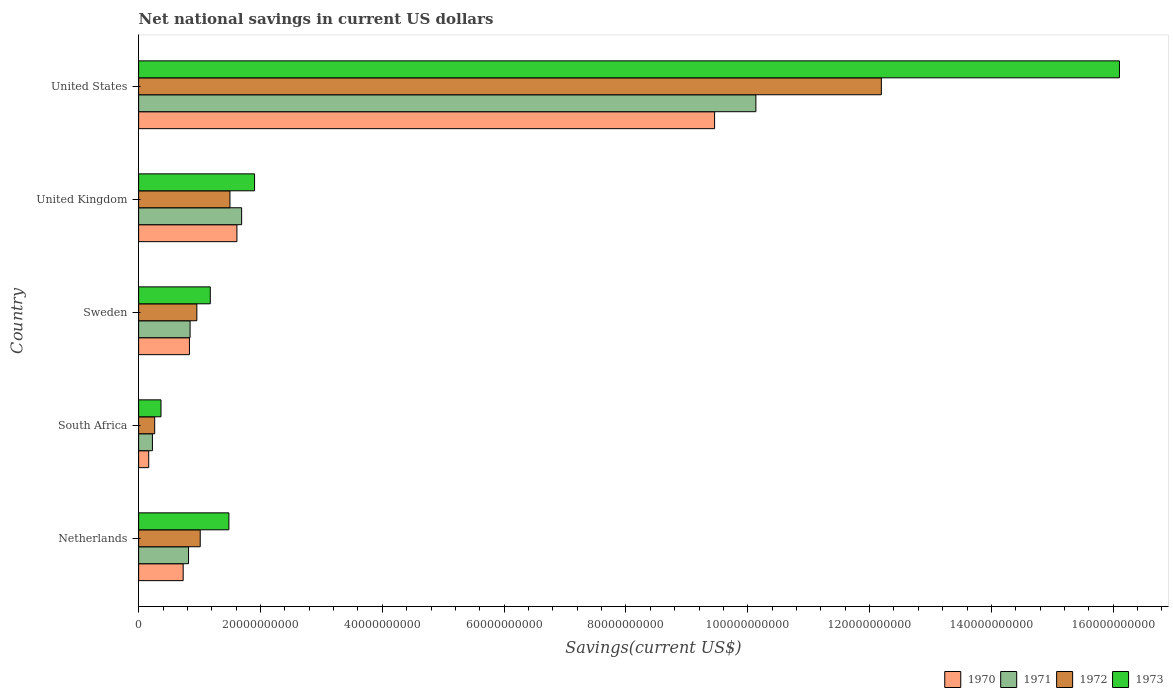How many groups of bars are there?
Offer a very short reply. 5. How many bars are there on the 3rd tick from the top?
Provide a succinct answer. 4. How many bars are there on the 5th tick from the bottom?
Give a very brief answer. 4. What is the net national savings in 1971 in United Kingdom?
Offer a terse response. 1.69e+1. Across all countries, what is the maximum net national savings in 1971?
Keep it short and to the point. 1.01e+11. Across all countries, what is the minimum net national savings in 1970?
Ensure brevity in your answer.  1.66e+09. In which country was the net national savings in 1970 maximum?
Provide a succinct answer. United States. In which country was the net national savings in 1970 minimum?
Give a very brief answer. South Africa. What is the total net national savings in 1972 in the graph?
Ensure brevity in your answer.  1.59e+11. What is the difference between the net national savings in 1970 in South Africa and that in United Kingdom?
Your response must be concise. -1.45e+1. What is the difference between the net national savings in 1973 in South Africa and the net national savings in 1971 in Netherlands?
Offer a very short reply. -4.52e+09. What is the average net national savings in 1973 per country?
Offer a very short reply. 4.21e+1. What is the difference between the net national savings in 1970 and net national savings in 1973 in South Africa?
Give a very brief answer. -2.02e+09. What is the ratio of the net national savings in 1970 in Netherlands to that in Sweden?
Your answer should be very brief. 0.88. Is the net national savings in 1973 in South Africa less than that in Sweden?
Offer a very short reply. Yes. What is the difference between the highest and the second highest net national savings in 1970?
Your answer should be very brief. 7.84e+1. What is the difference between the highest and the lowest net national savings in 1971?
Provide a succinct answer. 9.91e+1. What does the 3rd bar from the top in United Kingdom represents?
Provide a short and direct response. 1971. What does the 3rd bar from the bottom in South Africa represents?
Your answer should be very brief. 1972. Is it the case that in every country, the sum of the net national savings in 1972 and net national savings in 1971 is greater than the net national savings in 1973?
Give a very brief answer. Yes. Are all the bars in the graph horizontal?
Provide a short and direct response. Yes. What is the difference between two consecutive major ticks on the X-axis?
Ensure brevity in your answer.  2.00e+1. How many legend labels are there?
Keep it short and to the point. 4. What is the title of the graph?
Your response must be concise. Net national savings in current US dollars. What is the label or title of the X-axis?
Offer a very short reply. Savings(current US$). What is the label or title of the Y-axis?
Offer a terse response. Country. What is the Savings(current US$) of 1970 in Netherlands?
Your response must be concise. 7.31e+09. What is the Savings(current US$) in 1971 in Netherlands?
Your response must be concise. 8.20e+09. What is the Savings(current US$) of 1972 in Netherlands?
Give a very brief answer. 1.01e+1. What is the Savings(current US$) in 1973 in Netherlands?
Offer a very short reply. 1.48e+1. What is the Savings(current US$) in 1970 in South Africa?
Provide a short and direct response. 1.66e+09. What is the Savings(current US$) in 1971 in South Africa?
Your answer should be very brief. 2.27e+09. What is the Savings(current US$) in 1972 in South Africa?
Ensure brevity in your answer.  2.64e+09. What is the Savings(current US$) of 1973 in South Africa?
Provide a succinct answer. 3.67e+09. What is the Savings(current US$) in 1970 in Sweden?
Your answer should be compact. 8.34e+09. What is the Savings(current US$) in 1971 in Sweden?
Keep it short and to the point. 8.45e+09. What is the Savings(current US$) in 1972 in Sweden?
Offer a terse response. 9.56e+09. What is the Savings(current US$) of 1973 in Sweden?
Provide a succinct answer. 1.18e+1. What is the Savings(current US$) in 1970 in United Kingdom?
Your answer should be compact. 1.61e+1. What is the Savings(current US$) of 1971 in United Kingdom?
Your answer should be compact. 1.69e+1. What is the Savings(current US$) in 1972 in United Kingdom?
Your response must be concise. 1.50e+1. What is the Savings(current US$) in 1973 in United Kingdom?
Offer a very short reply. 1.90e+1. What is the Savings(current US$) of 1970 in United States?
Your answer should be compact. 9.46e+1. What is the Savings(current US$) in 1971 in United States?
Keep it short and to the point. 1.01e+11. What is the Savings(current US$) in 1972 in United States?
Provide a succinct answer. 1.22e+11. What is the Savings(current US$) of 1973 in United States?
Your answer should be compact. 1.61e+11. Across all countries, what is the maximum Savings(current US$) in 1970?
Offer a very short reply. 9.46e+1. Across all countries, what is the maximum Savings(current US$) of 1971?
Your answer should be very brief. 1.01e+11. Across all countries, what is the maximum Savings(current US$) in 1972?
Ensure brevity in your answer.  1.22e+11. Across all countries, what is the maximum Savings(current US$) of 1973?
Keep it short and to the point. 1.61e+11. Across all countries, what is the minimum Savings(current US$) in 1970?
Your response must be concise. 1.66e+09. Across all countries, what is the minimum Savings(current US$) in 1971?
Offer a terse response. 2.27e+09. Across all countries, what is the minimum Savings(current US$) in 1972?
Keep it short and to the point. 2.64e+09. Across all countries, what is the minimum Savings(current US$) of 1973?
Your answer should be compact. 3.67e+09. What is the total Savings(current US$) of 1970 in the graph?
Offer a terse response. 1.28e+11. What is the total Savings(current US$) of 1971 in the graph?
Keep it short and to the point. 1.37e+11. What is the total Savings(current US$) in 1972 in the graph?
Give a very brief answer. 1.59e+11. What is the total Savings(current US$) in 1973 in the graph?
Your answer should be very brief. 2.10e+11. What is the difference between the Savings(current US$) in 1970 in Netherlands and that in South Africa?
Your answer should be compact. 5.66e+09. What is the difference between the Savings(current US$) of 1971 in Netherlands and that in South Africa?
Your answer should be compact. 5.93e+09. What is the difference between the Savings(current US$) of 1972 in Netherlands and that in South Africa?
Ensure brevity in your answer.  7.48e+09. What is the difference between the Savings(current US$) of 1973 in Netherlands and that in South Africa?
Ensure brevity in your answer.  1.11e+1. What is the difference between the Savings(current US$) of 1970 in Netherlands and that in Sweden?
Your answer should be very brief. -1.03e+09. What is the difference between the Savings(current US$) in 1971 in Netherlands and that in Sweden?
Your response must be concise. -2.53e+08. What is the difference between the Savings(current US$) in 1972 in Netherlands and that in Sweden?
Ensure brevity in your answer.  5.54e+08. What is the difference between the Savings(current US$) in 1973 in Netherlands and that in Sweden?
Provide a short and direct response. 3.06e+09. What is the difference between the Savings(current US$) of 1970 in Netherlands and that in United Kingdom?
Your answer should be compact. -8.83e+09. What is the difference between the Savings(current US$) in 1971 in Netherlands and that in United Kingdom?
Keep it short and to the point. -8.72e+09. What is the difference between the Savings(current US$) of 1972 in Netherlands and that in United Kingdom?
Your answer should be very brief. -4.88e+09. What is the difference between the Savings(current US$) of 1973 in Netherlands and that in United Kingdom?
Your answer should be compact. -4.22e+09. What is the difference between the Savings(current US$) of 1970 in Netherlands and that in United States?
Offer a terse response. -8.72e+1. What is the difference between the Savings(current US$) in 1971 in Netherlands and that in United States?
Make the answer very short. -9.31e+1. What is the difference between the Savings(current US$) of 1972 in Netherlands and that in United States?
Provide a short and direct response. -1.12e+11. What is the difference between the Savings(current US$) in 1973 in Netherlands and that in United States?
Your answer should be compact. -1.46e+11. What is the difference between the Savings(current US$) of 1970 in South Africa and that in Sweden?
Keep it short and to the point. -6.69e+09. What is the difference between the Savings(current US$) in 1971 in South Africa and that in Sweden?
Offer a terse response. -6.18e+09. What is the difference between the Savings(current US$) of 1972 in South Africa and that in Sweden?
Your response must be concise. -6.92e+09. What is the difference between the Savings(current US$) of 1973 in South Africa and that in Sweden?
Provide a short and direct response. -8.09e+09. What is the difference between the Savings(current US$) of 1970 in South Africa and that in United Kingdom?
Give a very brief answer. -1.45e+1. What is the difference between the Savings(current US$) in 1971 in South Africa and that in United Kingdom?
Your answer should be compact. -1.46e+1. What is the difference between the Savings(current US$) in 1972 in South Africa and that in United Kingdom?
Make the answer very short. -1.24e+1. What is the difference between the Savings(current US$) of 1973 in South Africa and that in United Kingdom?
Provide a succinct answer. -1.54e+1. What is the difference between the Savings(current US$) in 1970 in South Africa and that in United States?
Give a very brief answer. -9.29e+1. What is the difference between the Savings(current US$) in 1971 in South Africa and that in United States?
Provide a succinct answer. -9.91e+1. What is the difference between the Savings(current US$) in 1972 in South Africa and that in United States?
Your answer should be very brief. -1.19e+11. What is the difference between the Savings(current US$) in 1973 in South Africa and that in United States?
Ensure brevity in your answer.  -1.57e+11. What is the difference between the Savings(current US$) in 1970 in Sweden and that in United Kingdom?
Provide a succinct answer. -7.80e+09. What is the difference between the Savings(current US$) of 1971 in Sweden and that in United Kingdom?
Ensure brevity in your answer.  -8.46e+09. What is the difference between the Savings(current US$) of 1972 in Sweden and that in United Kingdom?
Your response must be concise. -5.43e+09. What is the difference between the Savings(current US$) in 1973 in Sweden and that in United Kingdom?
Offer a very short reply. -7.27e+09. What is the difference between the Savings(current US$) of 1970 in Sweden and that in United States?
Your response must be concise. -8.62e+1. What is the difference between the Savings(current US$) in 1971 in Sweden and that in United States?
Ensure brevity in your answer.  -9.29e+1. What is the difference between the Savings(current US$) of 1972 in Sweden and that in United States?
Give a very brief answer. -1.12e+11. What is the difference between the Savings(current US$) of 1973 in Sweden and that in United States?
Provide a succinct answer. -1.49e+11. What is the difference between the Savings(current US$) of 1970 in United Kingdom and that in United States?
Your response must be concise. -7.84e+1. What is the difference between the Savings(current US$) in 1971 in United Kingdom and that in United States?
Give a very brief answer. -8.44e+1. What is the difference between the Savings(current US$) in 1972 in United Kingdom and that in United States?
Your response must be concise. -1.07e+11. What is the difference between the Savings(current US$) of 1973 in United Kingdom and that in United States?
Keep it short and to the point. -1.42e+11. What is the difference between the Savings(current US$) in 1970 in Netherlands and the Savings(current US$) in 1971 in South Africa?
Make the answer very short. 5.05e+09. What is the difference between the Savings(current US$) of 1970 in Netherlands and the Savings(current US$) of 1972 in South Africa?
Ensure brevity in your answer.  4.68e+09. What is the difference between the Savings(current US$) in 1970 in Netherlands and the Savings(current US$) in 1973 in South Africa?
Offer a very short reply. 3.64e+09. What is the difference between the Savings(current US$) in 1971 in Netherlands and the Savings(current US$) in 1972 in South Africa?
Offer a terse response. 5.56e+09. What is the difference between the Savings(current US$) of 1971 in Netherlands and the Savings(current US$) of 1973 in South Africa?
Your response must be concise. 4.52e+09. What is the difference between the Savings(current US$) in 1972 in Netherlands and the Savings(current US$) in 1973 in South Africa?
Provide a short and direct response. 6.44e+09. What is the difference between the Savings(current US$) in 1970 in Netherlands and the Savings(current US$) in 1971 in Sweden?
Offer a very short reply. -1.14e+09. What is the difference between the Savings(current US$) of 1970 in Netherlands and the Savings(current US$) of 1972 in Sweden?
Your answer should be compact. -2.25e+09. What is the difference between the Savings(current US$) of 1970 in Netherlands and the Savings(current US$) of 1973 in Sweden?
Offer a very short reply. -4.45e+09. What is the difference between the Savings(current US$) in 1971 in Netherlands and the Savings(current US$) in 1972 in Sweden?
Keep it short and to the point. -1.36e+09. What is the difference between the Savings(current US$) in 1971 in Netherlands and the Savings(current US$) in 1973 in Sweden?
Your answer should be compact. -3.57e+09. What is the difference between the Savings(current US$) of 1972 in Netherlands and the Savings(current US$) of 1973 in Sweden?
Keep it short and to the point. -1.65e+09. What is the difference between the Savings(current US$) of 1970 in Netherlands and the Savings(current US$) of 1971 in United Kingdom?
Keep it short and to the point. -9.60e+09. What is the difference between the Savings(current US$) in 1970 in Netherlands and the Savings(current US$) in 1972 in United Kingdom?
Offer a terse response. -7.68e+09. What is the difference between the Savings(current US$) of 1970 in Netherlands and the Savings(current US$) of 1973 in United Kingdom?
Ensure brevity in your answer.  -1.17e+1. What is the difference between the Savings(current US$) of 1971 in Netherlands and the Savings(current US$) of 1972 in United Kingdom?
Make the answer very short. -6.80e+09. What is the difference between the Savings(current US$) in 1971 in Netherlands and the Savings(current US$) in 1973 in United Kingdom?
Provide a succinct answer. -1.08e+1. What is the difference between the Savings(current US$) of 1972 in Netherlands and the Savings(current US$) of 1973 in United Kingdom?
Offer a terse response. -8.92e+09. What is the difference between the Savings(current US$) of 1970 in Netherlands and the Savings(current US$) of 1971 in United States?
Provide a short and direct response. -9.40e+1. What is the difference between the Savings(current US$) of 1970 in Netherlands and the Savings(current US$) of 1972 in United States?
Provide a succinct answer. -1.15e+11. What is the difference between the Savings(current US$) of 1970 in Netherlands and the Savings(current US$) of 1973 in United States?
Ensure brevity in your answer.  -1.54e+11. What is the difference between the Savings(current US$) in 1971 in Netherlands and the Savings(current US$) in 1972 in United States?
Your response must be concise. -1.14e+11. What is the difference between the Savings(current US$) in 1971 in Netherlands and the Savings(current US$) in 1973 in United States?
Your answer should be very brief. -1.53e+11. What is the difference between the Savings(current US$) in 1972 in Netherlands and the Savings(current US$) in 1973 in United States?
Your response must be concise. -1.51e+11. What is the difference between the Savings(current US$) of 1970 in South Africa and the Savings(current US$) of 1971 in Sweden?
Provide a short and direct response. -6.79e+09. What is the difference between the Savings(current US$) of 1970 in South Africa and the Savings(current US$) of 1972 in Sweden?
Make the answer very short. -7.90e+09. What is the difference between the Savings(current US$) of 1970 in South Africa and the Savings(current US$) of 1973 in Sweden?
Provide a succinct answer. -1.01e+1. What is the difference between the Savings(current US$) of 1971 in South Africa and the Savings(current US$) of 1972 in Sweden?
Your response must be concise. -7.29e+09. What is the difference between the Savings(current US$) in 1971 in South Africa and the Savings(current US$) in 1973 in Sweden?
Provide a short and direct response. -9.50e+09. What is the difference between the Savings(current US$) in 1972 in South Africa and the Savings(current US$) in 1973 in Sweden?
Ensure brevity in your answer.  -9.13e+09. What is the difference between the Savings(current US$) of 1970 in South Africa and the Savings(current US$) of 1971 in United Kingdom?
Make the answer very short. -1.53e+1. What is the difference between the Savings(current US$) in 1970 in South Africa and the Savings(current US$) in 1972 in United Kingdom?
Your answer should be very brief. -1.33e+1. What is the difference between the Savings(current US$) of 1970 in South Africa and the Savings(current US$) of 1973 in United Kingdom?
Ensure brevity in your answer.  -1.74e+1. What is the difference between the Savings(current US$) in 1971 in South Africa and the Savings(current US$) in 1972 in United Kingdom?
Offer a terse response. -1.27e+1. What is the difference between the Savings(current US$) of 1971 in South Africa and the Savings(current US$) of 1973 in United Kingdom?
Keep it short and to the point. -1.68e+1. What is the difference between the Savings(current US$) in 1972 in South Africa and the Savings(current US$) in 1973 in United Kingdom?
Your answer should be very brief. -1.64e+1. What is the difference between the Savings(current US$) of 1970 in South Africa and the Savings(current US$) of 1971 in United States?
Provide a short and direct response. -9.97e+1. What is the difference between the Savings(current US$) in 1970 in South Africa and the Savings(current US$) in 1972 in United States?
Your response must be concise. -1.20e+11. What is the difference between the Savings(current US$) in 1970 in South Africa and the Savings(current US$) in 1973 in United States?
Provide a short and direct response. -1.59e+11. What is the difference between the Savings(current US$) of 1971 in South Africa and the Savings(current US$) of 1972 in United States?
Ensure brevity in your answer.  -1.20e+11. What is the difference between the Savings(current US$) of 1971 in South Africa and the Savings(current US$) of 1973 in United States?
Your answer should be very brief. -1.59e+11. What is the difference between the Savings(current US$) in 1972 in South Africa and the Savings(current US$) in 1973 in United States?
Offer a very short reply. -1.58e+11. What is the difference between the Savings(current US$) of 1970 in Sweden and the Savings(current US$) of 1971 in United Kingdom?
Provide a short and direct response. -8.57e+09. What is the difference between the Savings(current US$) of 1970 in Sweden and the Savings(current US$) of 1972 in United Kingdom?
Give a very brief answer. -6.65e+09. What is the difference between the Savings(current US$) of 1970 in Sweden and the Savings(current US$) of 1973 in United Kingdom?
Ensure brevity in your answer.  -1.07e+1. What is the difference between the Savings(current US$) in 1971 in Sweden and the Savings(current US$) in 1972 in United Kingdom?
Give a very brief answer. -6.54e+09. What is the difference between the Savings(current US$) of 1971 in Sweden and the Savings(current US$) of 1973 in United Kingdom?
Make the answer very short. -1.06e+1. What is the difference between the Savings(current US$) of 1972 in Sweden and the Savings(current US$) of 1973 in United Kingdom?
Keep it short and to the point. -9.48e+09. What is the difference between the Savings(current US$) in 1970 in Sweden and the Savings(current US$) in 1971 in United States?
Offer a very short reply. -9.30e+1. What is the difference between the Savings(current US$) in 1970 in Sweden and the Savings(current US$) in 1972 in United States?
Give a very brief answer. -1.14e+11. What is the difference between the Savings(current US$) in 1970 in Sweden and the Savings(current US$) in 1973 in United States?
Provide a succinct answer. -1.53e+11. What is the difference between the Savings(current US$) in 1971 in Sweden and the Savings(current US$) in 1972 in United States?
Your answer should be compact. -1.13e+11. What is the difference between the Savings(current US$) in 1971 in Sweden and the Savings(current US$) in 1973 in United States?
Your answer should be compact. -1.53e+11. What is the difference between the Savings(current US$) in 1972 in Sweden and the Savings(current US$) in 1973 in United States?
Your response must be concise. -1.51e+11. What is the difference between the Savings(current US$) of 1970 in United Kingdom and the Savings(current US$) of 1971 in United States?
Your answer should be compact. -8.52e+1. What is the difference between the Savings(current US$) in 1970 in United Kingdom and the Savings(current US$) in 1972 in United States?
Your answer should be compact. -1.06e+11. What is the difference between the Savings(current US$) in 1970 in United Kingdom and the Savings(current US$) in 1973 in United States?
Make the answer very short. -1.45e+11. What is the difference between the Savings(current US$) in 1971 in United Kingdom and the Savings(current US$) in 1972 in United States?
Provide a short and direct response. -1.05e+11. What is the difference between the Savings(current US$) of 1971 in United Kingdom and the Savings(current US$) of 1973 in United States?
Keep it short and to the point. -1.44e+11. What is the difference between the Savings(current US$) of 1972 in United Kingdom and the Savings(current US$) of 1973 in United States?
Give a very brief answer. -1.46e+11. What is the average Savings(current US$) of 1970 per country?
Your answer should be very brief. 2.56e+1. What is the average Savings(current US$) in 1971 per country?
Provide a succinct answer. 2.74e+1. What is the average Savings(current US$) in 1972 per country?
Offer a terse response. 3.18e+1. What is the average Savings(current US$) in 1973 per country?
Ensure brevity in your answer.  4.21e+1. What is the difference between the Savings(current US$) in 1970 and Savings(current US$) in 1971 in Netherlands?
Provide a succinct answer. -8.83e+08. What is the difference between the Savings(current US$) of 1970 and Savings(current US$) of 1972 in Netherlands?
Your answer should be very brief. -2.80e+09. What is the difference between the Savings(current US$) in 1970 and Savings(current US$) in 1973 in Netherlands?
Provide a short and direct response. -7.51e+09. What is the difference between the Savings(current US$) of 1971 and Savings(current US$) of 1972 in Netherlands?
Your answer should be very brief. -1.92e+09. What is the difference between the Savings(current US$) in 1971 and Savings(current US$) in 1973 in Netherlands?
Offer a very short reply. -6.62e+09. What is the difference between the Savings(current US$) in 1972 and Savings(current US$) in 1973 in Netherlands?
Make the answer very short. -4.71e+09. What is the difference between the Savings(current US$) of 1970 and Savings(current US$) of 1971 in South Africa?
Keep it short and to the point. -6.09e+08. What is the difference between the Savings(current US$) in 1970 and Savings(current US$) in 1972 in South Africa?
Give a very brief answer. -9.79e+08. What is the difference between the Savings(current US$) in 1970 and Savings(current US$) in 1973 in South Africa?
Your answer should be very brief. -2.02e+09. What is the difference between the Savings(current US$) in 1971 and Savings(current US$) in 1972 in South Africa?
Provide a succinct answer. -3.70e+08. What is the difference between the Savings(current US$) of 1971 and Savings(current US$) of 1973 in South Africa?
Offer a terse response. -1.41e+09. What is the difference between the Savings(current US$) in 1972 and Savings(current US$) in 1973 in South Africa?
Make the answer very short. -1.04e+09. What is the difference between the Savings(current US$) in 1970 and Savings(current US$) in 1971 in Sweden?
Your answer should be very brief. -1.07e+08. What is the difference between the Savings(current US$) in 1970 and Savings(current US$) in 1972 in Sweden?
Your answer should be compact. -1.22e+09. What is the difference between the Savings(current US$) in 1970 and Savings(current US$) in 1973 in Sweden?
Your answer should be compact. -3.42e+09. What is the difference between the Savings(current US$) of 1971 and Savings(current US$) of 1972 in Sweden?
Provide a succinct answer. -1.11e+09. What is the difference between the Savings(current US$) in 1971 and Savings(current US$) in 1973 in Sweden?
Your response must be concise. -3.31e+09. What is the difference between the Savings(current US$) of 1972 and Savings(current US$) of 1973 in Sweden?
Keep it short and to the point. -2.20e+09. What is the difference between the Savings(current US$) of 1970 and Savings(current US$) of 1971 in United Kingdom?
Your answer should be compact. -7.74e+08. What is the difference between the Savings(current US$) of 1970 and Savings(current US$) of 1972 in United Kingdom?
Offer a terse response. 1.15e+09. What is the difference between the Savings(current US$) in 1970 and Savings(current US$) in 1973 in United Kingdom?
Your answer should be very brief. -2.90e+09. What is the difference between the Savings(current US$) in 1971 and Savings(current US$) in 1972 in United Kingdom?
Your response must be concise. 1.92e+09. What is the difference between the Savings(current US$) of 1971 and Savings(current US$) of 1973 in United Kingdom?
Ensure brevity in your answer.  -2.12e+09. What is the difference between the Savings(current US$) in 1972 and Savings(current US$) in 1973 in United Kingdom?
Make the answer very short. -4.04e+09. What is the difference between the Savings(current US$) of 1970 and Savings(current US$) of 1971 in United States?
Provide a short and direct response. -6.78e+09. What is the difference between the Savings(current US$) in 1970 and Savings(current US$) in 1972 in United States?
Your answer should be compact. -2.74e+1. What is the difference between the Savings(current US$) of 1970 and Savings(current US$) of 1973 in United States?
Provide a short and direct response. -6.65e+1. What is the difference between the Savings(current US$) in 1971 and Savings(current US$) in 1972 in United States?
Ensure brevity in your answer.  -2.06e+1. What is the difference between the Savings(current US$) of 1971 and Savings(current US$) of 1973 in United States?
Your response must be concise. -5.97e+1. What is the difference between the Savings(current US$) in 1972 and Savings(current US$) in 1973 in United States?
Your response must be concise. -3.91e+1. What is the ratio of the Savings(current US$) of 1970 in Netherlands to that in South Africa?
Your response must be concise. 4.42. What is the ratio of the Savings(current US$) of 1971 in Netherlands to that in South Africa?
Ensure brevity in your answer.  3.62. What is the ratio of the Savings(current US$) in 1972 in Netherlands to that in South Africa?
Your answer should be compact. 3.84. What is the ratio of the Savings(current US$) in 1973 in Netherlands to that in South Africa?
Offer a very short reply. 4.04. What is the ratio of the Savings(current US$) in 1970 in Netherlands to that in Sweden?
Provide a succinct answer. 0.88. What is the ratio of the Savings(current US$) in 1972 in Netherlands to that in Sweden?
Ensure brevity in your answer.  1.06. What is the ratio of the Savings(current US$) of 1973 in Netherlands to that in Sweden?
Give a very brief answer. 1.26. What is the ratio of the Savings(current US$) of 1970 in Netherlands to that in United Kingdom?
Offer a very short reply. 0.45. What is the ratio of the Savings(current US$) in 1971 in Netherlands to that in United Kingdom?
Keep it short and to the point. 0.48. What is the ratio of the Savings(current US$) in 1972 in Netherlands to that in United Kingdom?
Your answer should be compact. 0.67. What is the ratio of the Savings(current US$) of 1973 in Netherlands to that in United Kingdom?
Your response must be concise. 0.78. What is the ratio of the Savings(current US$) in 1970 in Netherlands to that in United States?
Provide a succinct answer. 0.08. What is the ratio of the Savings(current US$) in 1971 in Netherlands to that in United States?
Offer a terse response. 0.08. What is the ratio of the Savings(current US$) in 1972 in Netherlands to that in United States?
Your answer should be compact. 0.08. What is the ratio of the Savings(current US$) of 1973 in Netherlands to that in United States?
Keep it short and to the point. 0.09. What is the ratio of the Savings(current US$) in 1970 in South Africa to that in Sweden?
Give a very brief answer. 0.2. What is the ratio of the Savings(current US$) of 1971 in South Africa to that in Sweden?
Offer a very short reply. 0.27. What is the ratio of the Savings(current US$) in 1972 in South Africa to that in Sweden?
Your response must be concise. 0.28. What is the ratio of the Savings(current US$) in 1973 in South Africa to that in Sweden?
Offer a very short reply. 0.31. What is the ratio of the Savings(current US$) of 1970 in South Africa to that in United Kingdom?
Provide a short and direct response. 0.1. What is the ratio of the Savings(current US$) of 1971 in South Africa to that in United Kingdom?
Keep it short and to the point. 0.13. What is the ratio of the Savings(current US$) in 1972 in South Africa to that in United Kingdom?
Your answer should be very brief. 0.18. What is the ratio of the Savings(current US$) in 1973 in South Africa to that in United Kingdom?
Make the answer very short. 0.19. What is the ratio of the Savings(current US$) of 1970 in South Africa to that in United States?
Your answer should be compact. 0.02. What is the ratio of the Savings(current US$) in 1971 in South Africa to that in United States?
Your answer should be very brief. 0.02. What is the ratio of the Savings(current US$) in 1972 in South Africa to that in United States?
Give a very brief answer. 0.02. What is the ratio of the Savings(current US$) in 1973 in South Africa to that in United States?
Keep it short and to the point. 0.02. What is the ratio of the Savings(current US$) of 1970 in Sweden to that in United Kingdom?
Make the answer very short. 0.52. What is the ratio of the Savings(current US$) of 1971 in Sweden to that in United Kingdom?
Make the answer very short. 0.5. What is the ratio of the Savings(current US$) of 1972 in Sweden to that in United Kingdom?
Your response must be concise. 0.64. What is the ratio of the Savings(current US$) in 1973 in Sweden to that in United Kingdom?
Offer a terse response. 0.62. What is the ratio of the Savings(current US$) of 1970 in Sweden to that in United States?
Give a very brief answer. 0.09. What is the ratio of the Savings(current US$) in 1971 in Sweden to that in United States?
Offer a very short reply. 0.08. What is the ratio of the Savings(current US$) in 1972 in Sweden to that in United States?
Make the answer very short. 0.08. What is the ratio of the Savings(current US$) in 1973 in Sweden to that in United States?
Give a very brief answer. 0.07. What is the ratio of the Savings(current US$) of 1970 in United Kingdom to that in United States?
Keep it short and to the point. 0.17. What is the ratio of the Savings(current US$) of 1971 in United Kingdom to that in United States?
Your response must be concise. 0.17. What is the ratio of the Savings(current US$) of 1972 in United Kingdom to that in United States?
Your answer should be very brief. 0.12. What is the ratio of the Savings(current US$) in 1973 in United Kingdom to that in United States?
Give a very brief answer. 0.12. What is the difference between the highest and the second highest Savings(current US$) of 1970?
Provide a succinct answer. 7.84e+1. What is the difference between the highest and the second highest Savings(current US$) in 1971?
Provide a succinct answer. 8.44e+1. What is the difference between the highest and the second highest Savings(current US$) of 1972?
Keep it short and to the point. 1.07e+11. What is the difference between the highest and the second highest Savings(current US$) in 1973?
Provide a short and direct response. 1.42e+11. What is the difference between the highest and the lowest Savings(current US$) of 1970?
Provide a short and direct response. 9.29e+1. What is the difference between the highest and the lowest Savings(current US$) of 1971?
Give a very brief answer. 9.91e+1. What is the difference between the highest and the lowest Savings(current US$) of 1972?
Your answer should be compact. 1.19e+11. What is the difference between the highest and the lowest Savings(current US$) in 1973?
Your answer should be very brief. 1.57e+11. 